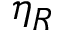Convert formula to latex. <formula><loc_0><loc_0><loc_500><loc_500>\eta _ { R }</formula> 